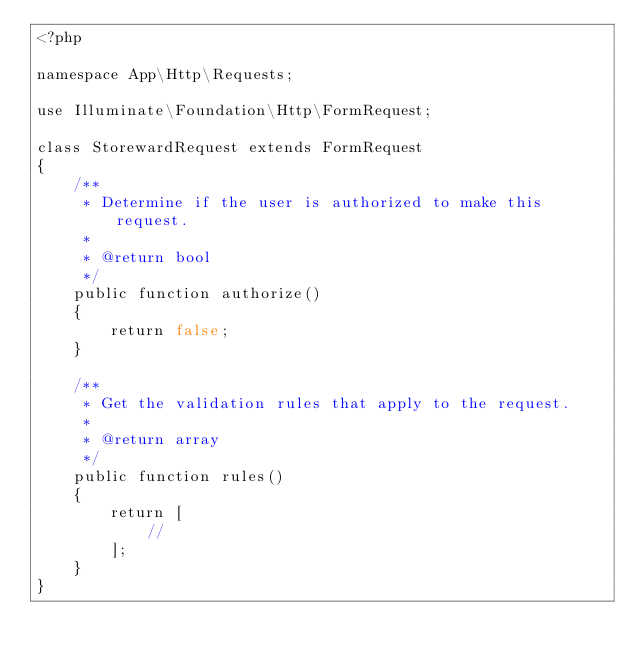<code> <loc_0><loc_0><loc_500><loc_500><_PHP_><?php

namespace App\Http\Requests;

use Illuminate\Foundation\Http\FormRequest;

class StorewardRequest extends FormRequest
{
    /**
     * Determine if the user is authorized to make this request.
     *
     * @return bool
     */
    public function authorize()
    {
        return false;
    }

    /**
     * Get the validation rules that apply to the request.
     *
     * @return array
     */
    public function rules()
    {
        return [
            //
        ];
    }
}
</code> 